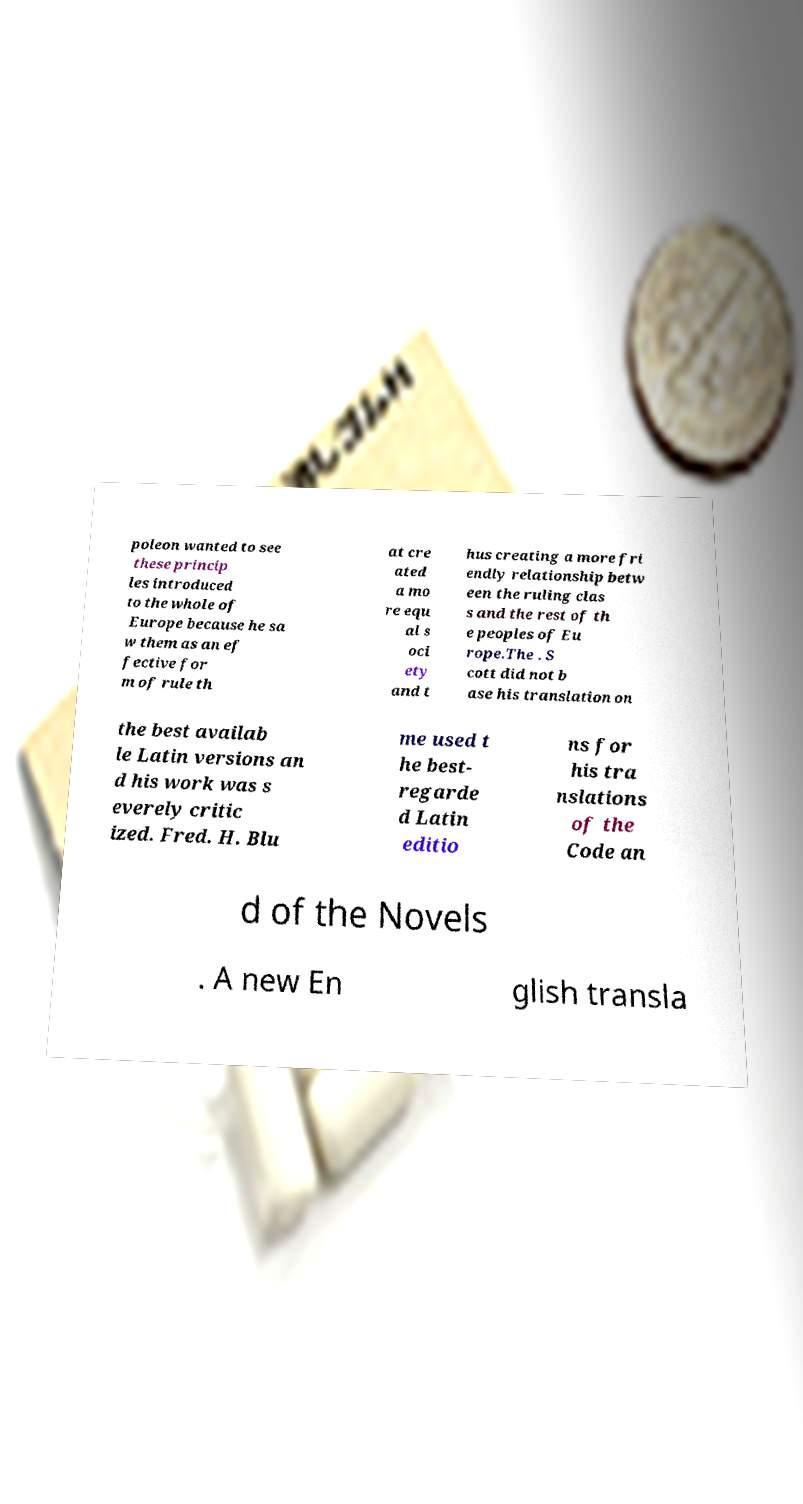What messages or text are displayed in this image? I need them in a readable, typed format. poleon wanted to see these princip les introduced to the whole of Europe because he sa w them as an ef fective for m of rule th at cre ated a mo re equ al s oci ety and t hus creating a more fri endly relationship betw een the ruling clas s and the rest of th e peoples of Eu rope.The . S cott did not b ase his translation on the best availab le Latin versions an d his work was s everely critic ized. Fred. H. Blu me used t he best- regarde d Latin editio ns for his tra nslations of the Code an d of the Novels . A new En glish transla 